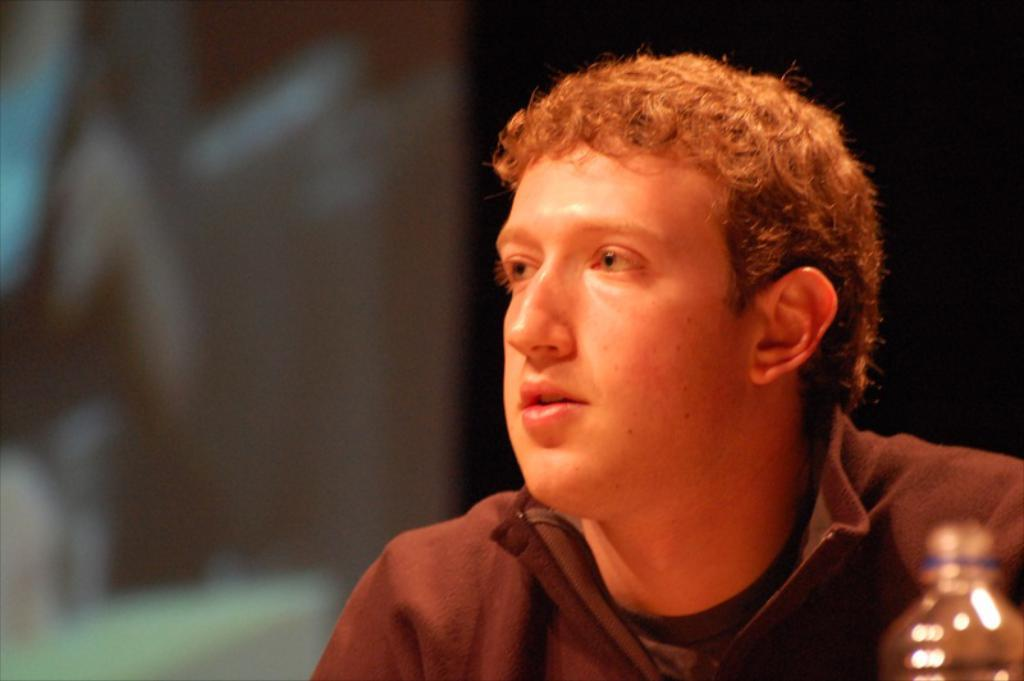Who is present in the image? There is a man in the image. What object can be seen in the image? There is a bottle in the image. Can you describe the background of the image? The background of the image is blurry. What type of event is taking place in the image? There is no indication of an event taking place in the image. The image only shows a man and a bottle with a blurry background. 